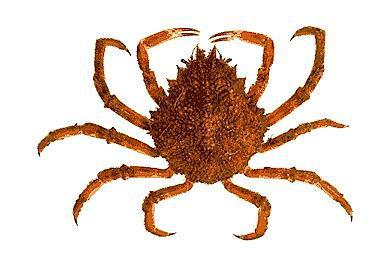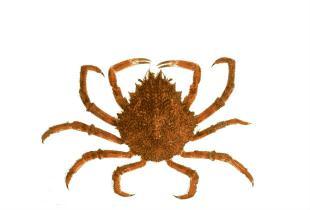The first image is the image on the left, the second image is the image on the right. Examine the images to the left and right. Is the description "The left and right image contains the same number of crabs facing the same direction." accurate? Answer yes or no. Yes. The first image is the image on the left, the second image is the image on the right. Examine the images to the left and right. Is the description "Both crabs are facing the same direction." accurate? Answer yes or no. Yes. 